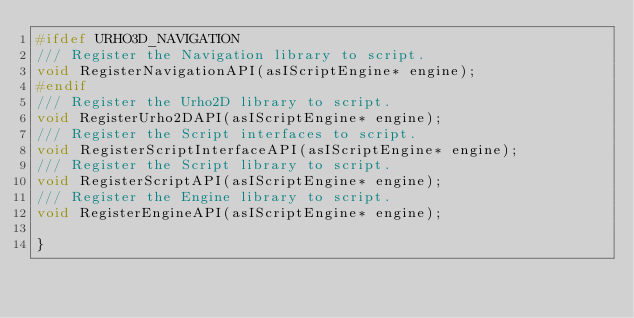Convert code to text. <code><loc_0><loc_0><loc_500><loc_500><_C_>#ifdef URHO3D_NAVIGATION
/// Register the Navigation library to script.
void RegisterNavigationAPI(asIScriptEngine* engine);
#endif
/// Register the Urho2D library to script.
void RegisterUrho2DAPI(asIScriptEngine* engine);
/// Register the Script interfaces to script.
void RegisterScriptInterfaceAPI(asIScriptEngine* engine);
/// Register the Script library to script.
void RegisterScriptAPI(asIScriptEngine* engine);
/// Register the Engine library to script.
void RegisterEngineAPI(asIScriptEngine* engine);

}
</code> 